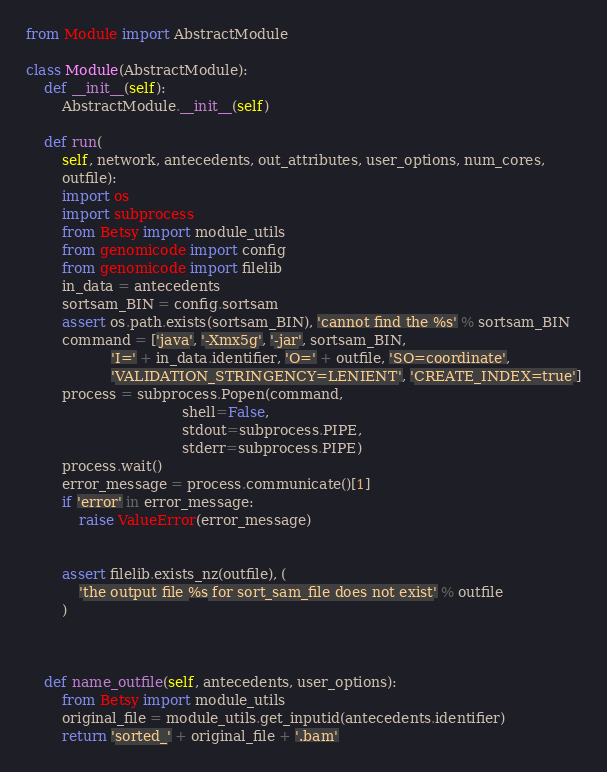<code> <loc_0><loc_0><loc_500><loc_500><_Python_>from Module import AbstractModule

class Module(AbstractModule):
    def __init__(self):
        AbstractModule.__init__(self)

    def run(
        self, network, antecedents, out_attributes, user_options, num_cores,
        outfile):
        import os
        import subprocess
        from Betsy import module_utils
        from genomicode import config
        from genomicode import filelib
        in_data = antecedents
        sortsam_BIN = config.sortsam
        assert os.path.exists(sortsam_BIN), 'cannot find the %s' % sortsam_BIN
        command = ['java', '-Xmx5g', '-jar', sortsam_BIN,
                   'I=' + in_data.identifier, 'O=' + outfile, 'SO=coordinate',
                   'VALIDATION_STRINGENCY=LENIENT', 'CREATE_INDEX=true']
        process = subprocess.Popen(command,
                                   shell=False,
                                   stdout=subprocess.PIPE,
                                   stderr=subprocess.PIPE)
        process.wait()
        error_message = process.communicate()[1]
        if 'error' in error_message:
            raise ValueError(error_message)
    
        
        assert filelib.exists_nz(outfile), (
            'the output file %s for sort_sam_file does not exist' % outfile
        )



    def name_outfile(self, antecedents, user_options):
        from Betsy import module_utils
        original_file = module_utils.get_inputid(antecedents.identifier)
        return 'sorted_' + original_file + '.bam'

</code> 